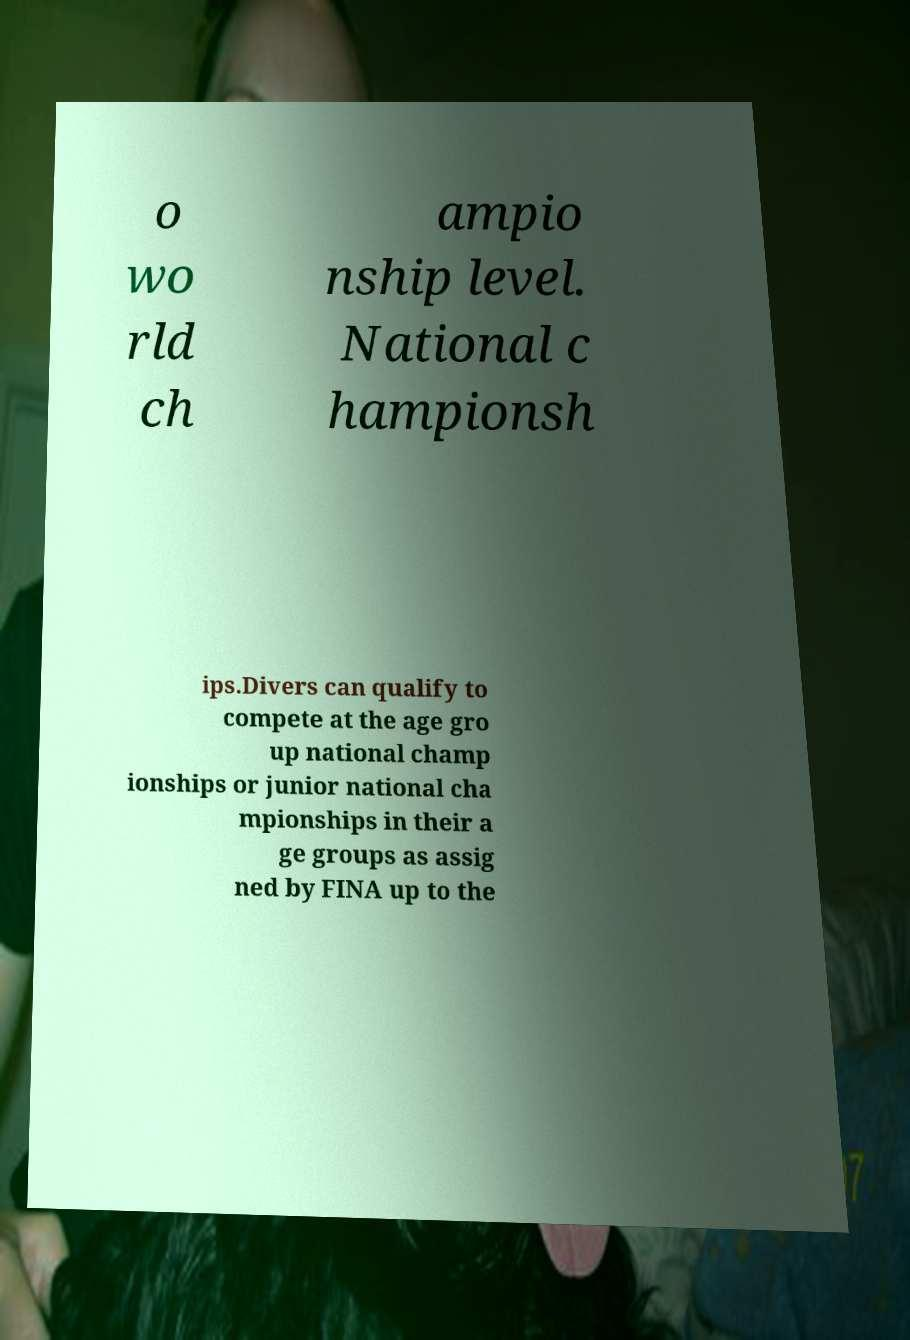Please identify and transcribe the text found in this image. o wo rld ch ampio nship level. National c hampionsh ips.Divers can qualify to compete at the age gro up national champ ionships or junior national cha mpionships in their a ge groups as assig ned by FINA up to the 